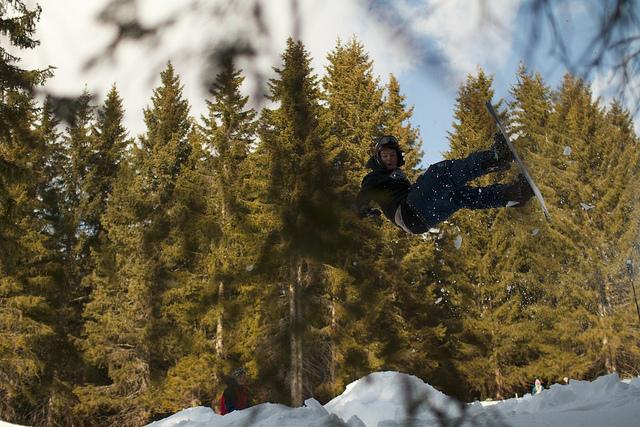Is the picture clear?
Give a very brief answer. No. Has much snow fallen?
Write a very short answer. Lot. How did the guy get in the air?
Quick response, please. Jumped. What is blocking the picture?
Be succinct. Tree branch. Is there snow on the trees?
Answer briefly. No. 